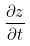<formula> <loc_0><loc_0><loc_500><loc_500>\frac { \partial z } { \partial t }</formula> 